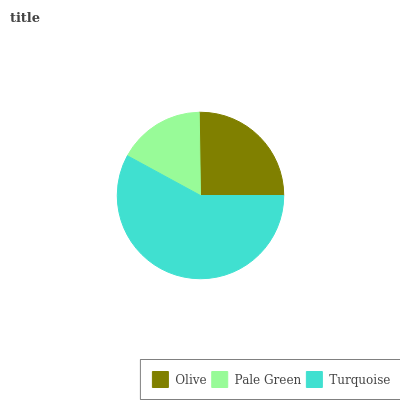Is Pale Green the minimum?
Answer yes or no. Yes. Is Turquoise the maximum?
Answer yes or no. Yes. Is Turquoise the minimum?
Answer yes or no. No. Is Pale Green the maximum?
Answer yes or no. No. Is Turquoise greater than Pale Green?
Answer yes or no. Yes. Is Pale Green less than Turquoise?
Answer yes or no. Yes. Is Pale Green greater than Turquoise?
Answer yes or no. No. Is Turquoise less than Pale Green?
Answer yes or no. No. Is Olive the high median?
Answer yes or no. Yes. Is Olive the low median?
Answer yes or no. Yes. Is Turquoise the high median?
Answer yes or no. No. Is Pale Green the low median?
Answer yes or no. No. 